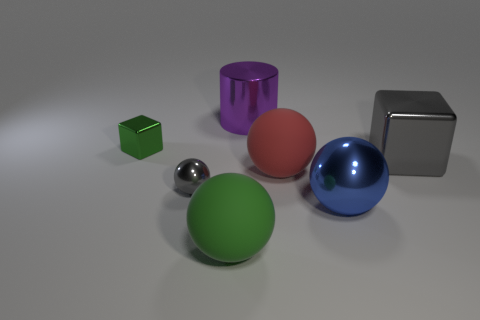Is the material of the big gray block the same as the tiny object behind the big metal block?
Keep it short and to the point. Yes. What number of things are large things in front of the large gray thing or matte balls behind the big green thing?
Your answer should be compact. 3. The tiny cube has what color?
Your answer should be very brief. Green. Are there fewer large shiny cylinders that are on the right side of the green metallic cube than purple metallic cylinders?
Your answer should be very brief. No. Is there any other thing that is the same shape as the big purple object?
Give a very brief answer. No. Is there a large matte thing?
Make the answer very short. Yes. Is the number of small gray shiny balls less than the number of big gray spheres?
Offer a very short reply. No. How many small things are made of the same material as the big red sphere?
Provide a short and direct response. 0. The tiny block that is made of the same material as the big cube is what color?
Your answer should be very brief. Green. The large gray object is what shape?
Ensure brevity in your answer.  Cube. 